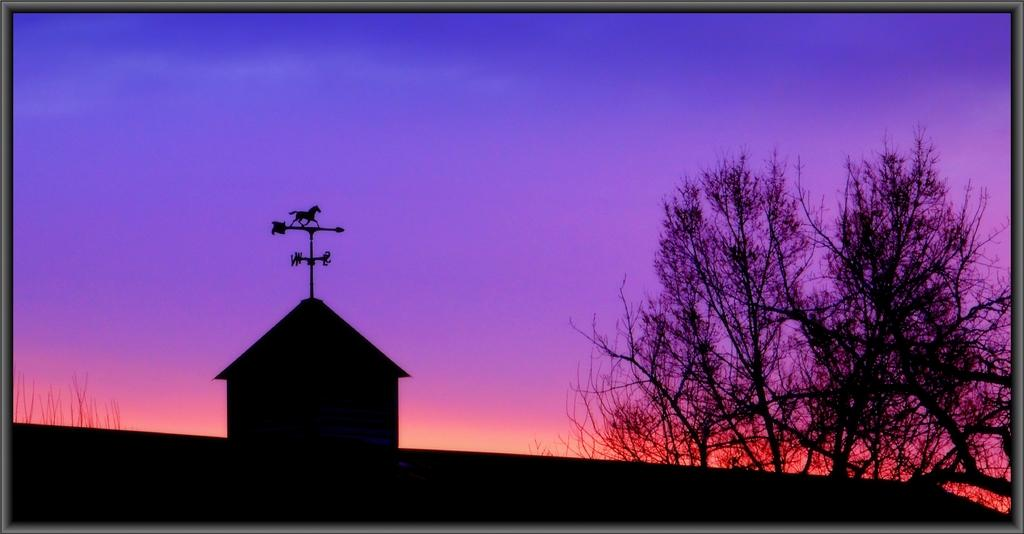What type of structure is visible in the image? There is a house in the image. What can be seen on the right side of the image? There are trees on the right side of the image. How would you describe the weather based on the image? The sky is clear in the image, suggesting good weather. Can you identify any objects placed on the house? Yes, there is an object placed on the house. How does the leaf on the house interact with the quill in the image? There is no leaf or quill present in the image. 